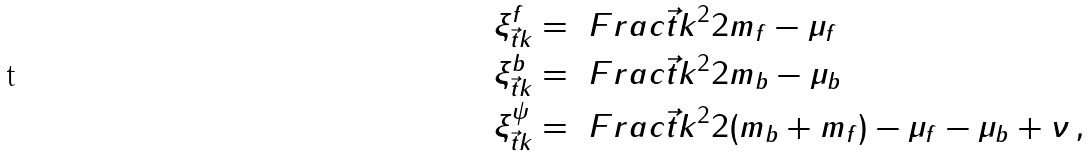<formula> <loc_0><loc_0><loc_500><loc_500>\xi ^ { f } _ { \vec { t } { k } } & = \ F r a c { \vec { t } { k } ^ { 2 } } { 2 m _ { f } } - \mu _ { f } \\ \xi ^ { b } _ { \vec { t } { k } } & = \ F r a c { \vec { t } { k } ^ { 2 } } { 2 m _ { b } } - \mu _ { b } \\ \xi ^ { \psi } _ { \vec { t } { k } } & = \ F r a c { \vec { t } { k } ^ { 2 } } { 2 ( m _ { b } + m _ { f } ) } - \mu _ { f } - \mu _ { b } + \nu \, ,</formula> 